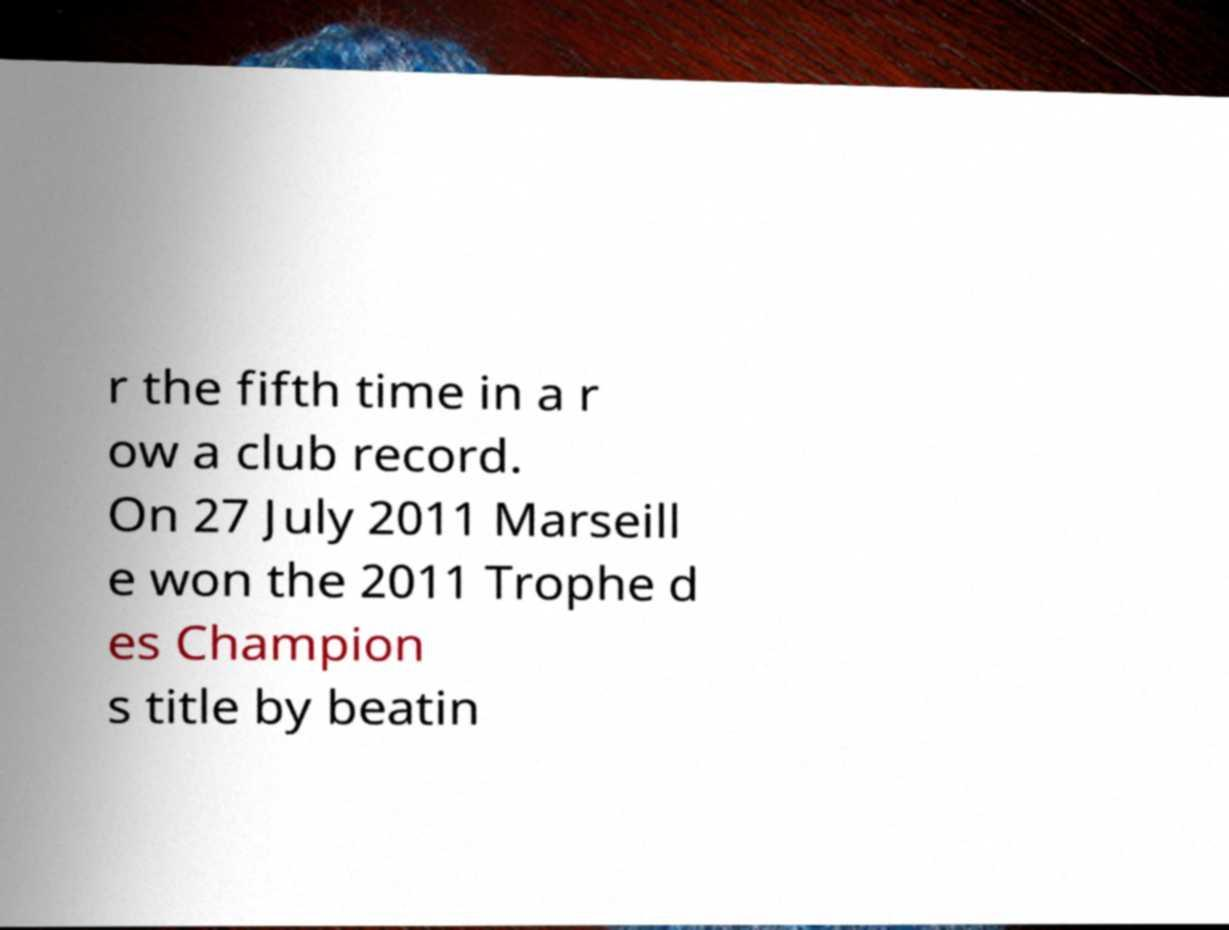What messages or text are displayed in this image? I need them in a readable, typed format. r the fifth time in a r ow a club record. On 27 July 2011 Marseill e won the 2011 Trophe d es Champion s title by beatin 